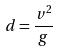<formula> <loc_0><loc_0><loc_500><loc_500>d = \frac { v ^ { 2 } } { g }</formula> 